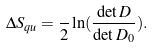<formula> <loc_0><loc_0><loc_500><loc_500>\Delta S _ { q u } = \frac { } { 2 } \ln ( \frac { \det { D } } { \det { D _ { 0 } } } ) .</formula> 